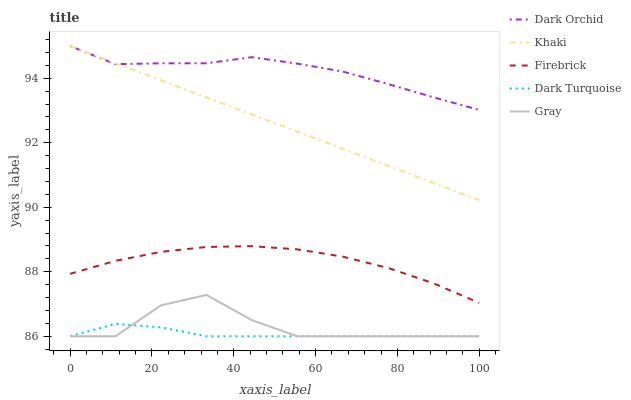Does Firebrick have the minimum area under the curve?
Answer yes or no. No. Does Firebrick have the maximum area under the curve?
Answer yes or no. No. Is Firebrick the smoothest?
Answer yes or no. No. Is Firebrick the roughest?
Answer yes or no. No. Does Firebrick have the lowest value?
Answer yes or no. No. Does Firebrick have the highest value?
Answer yes or no. No. Is Gray less than Khaki?
Answer yes or no. Yes. Is Dark Orchid greater than Dark Turquoise?
Answer yes or no. Yes. Does Gray intersect Khaki?
Answer yes or no. No. 